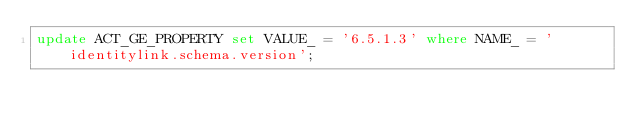Convert code to text. <code><loc_0><loc_0><loc_500><loc_500><_SQL_>update ACT_GE_PROPERTY set VALUE_ = '6.5.1.3' where NAME_ = 'identitylink.schema.version';
</code> 